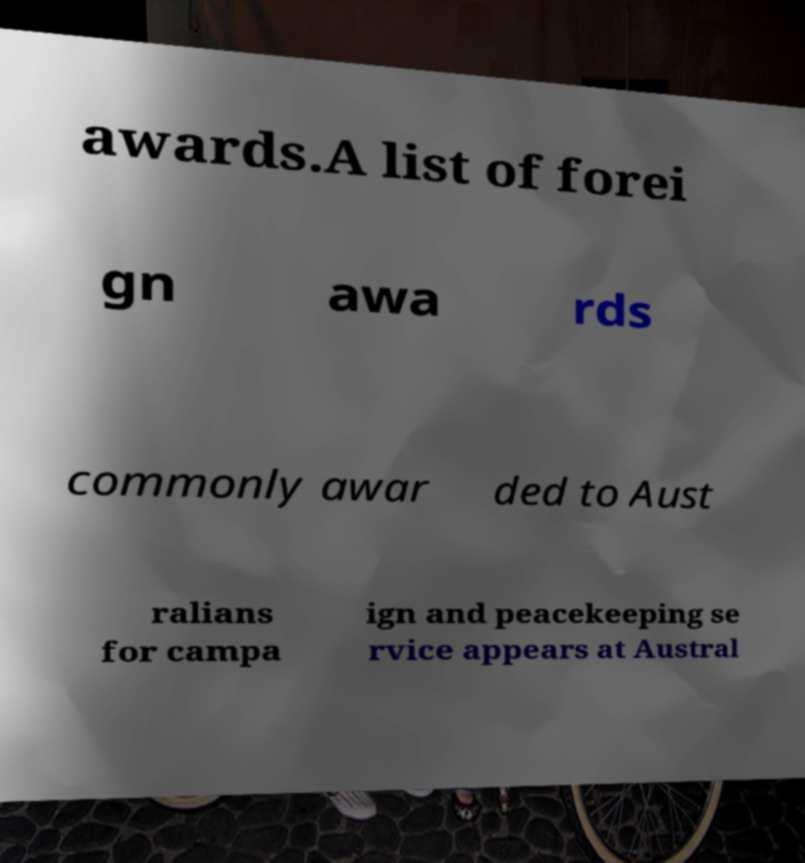What messages or text are displayed in this image? I need them in a readable, typed format. awards.A list of forei gn awa rds commonly awar ded to Aust ralians for campa ign and peacekeeping se rvice appears at Austral 